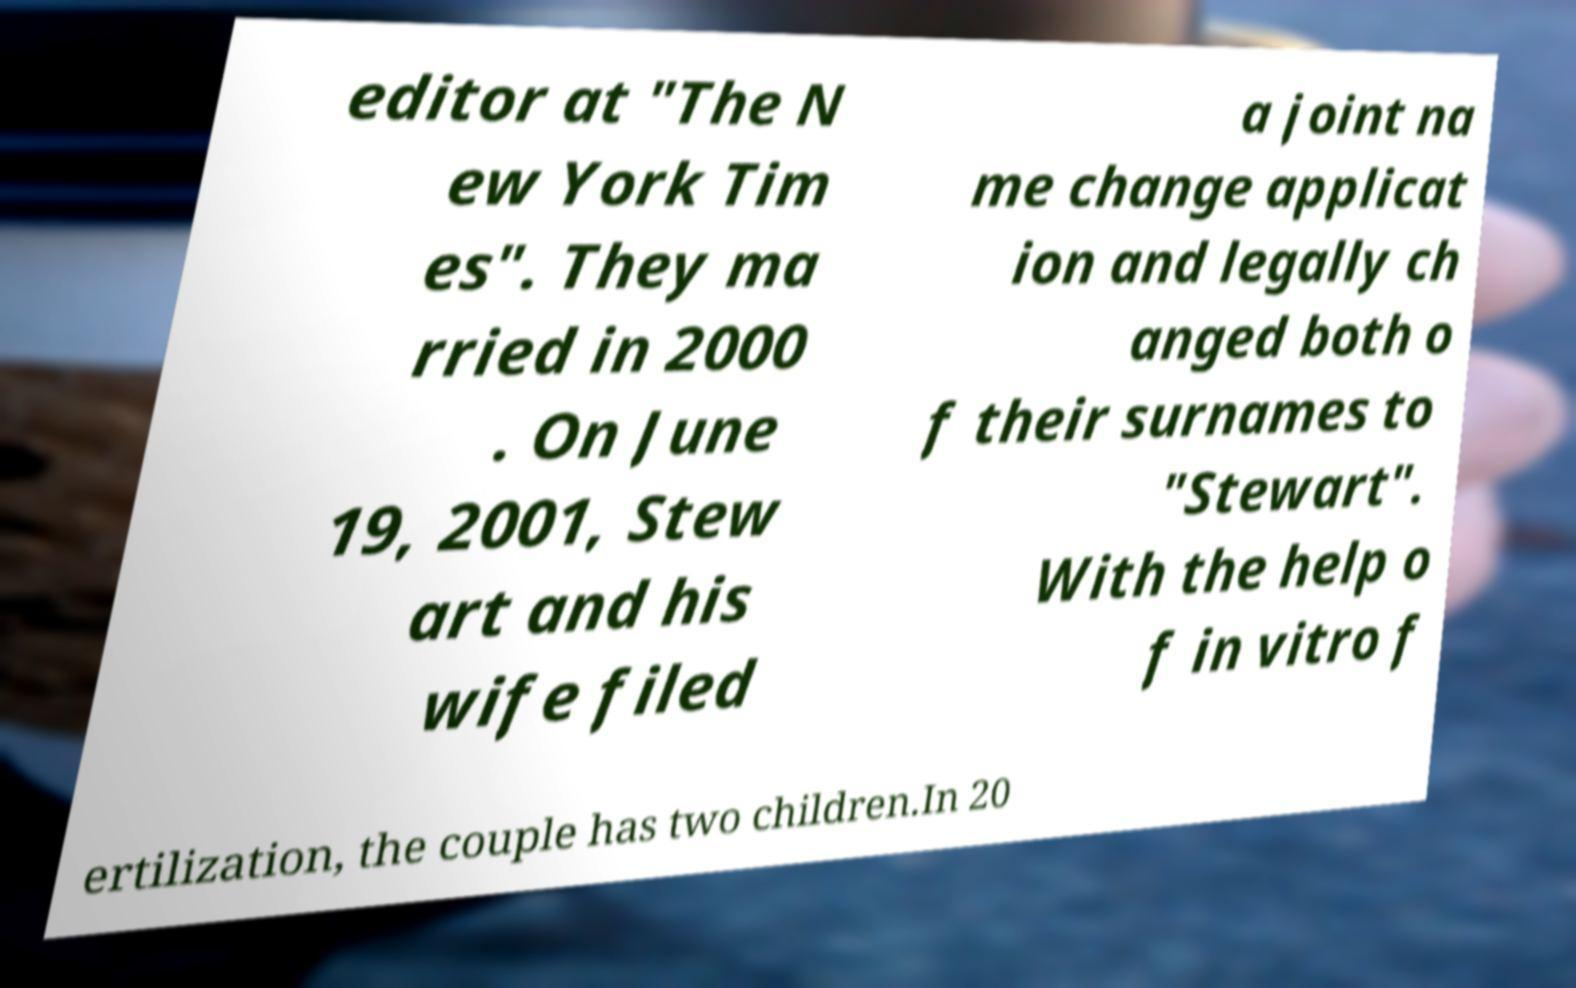Please identify and transcribe the text found in this image. editor at "The N ew York Tim es". They ma rried in 2000 . On June 19, 2001, Stew art and his wife filed a joint na me change applicat ion and legally ch anged both o f their surnames to "Stewart". With the help o f in vitro f ertilization, the couple has two children.In 20 